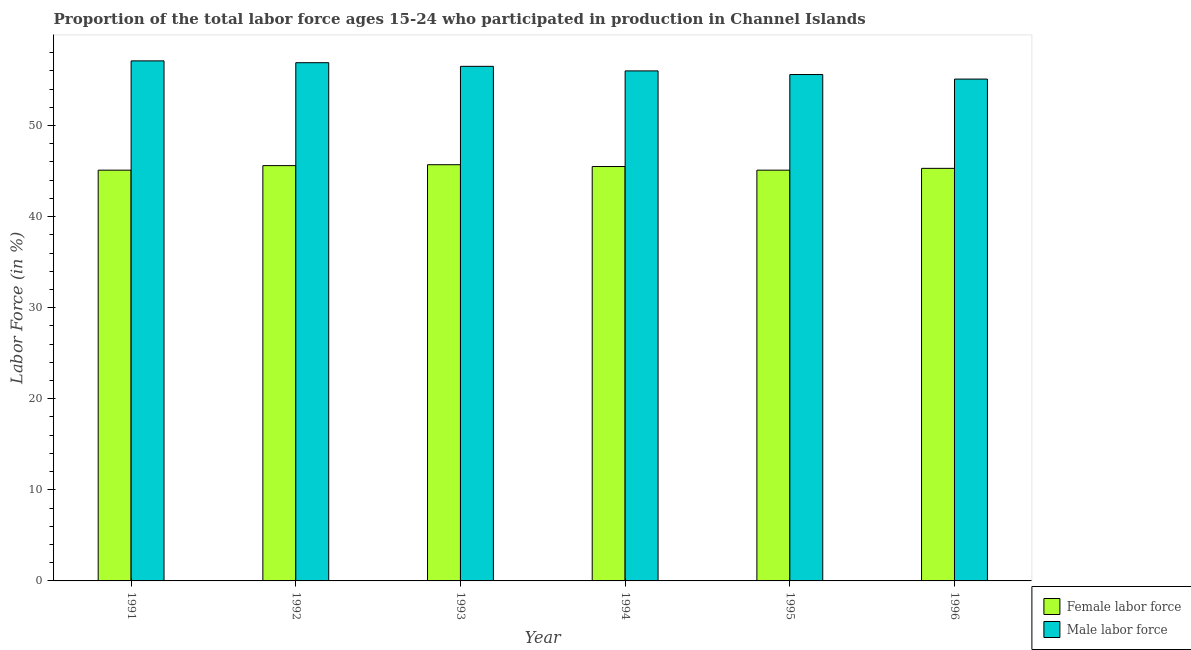How many groups of bars are there?
Your response must be concise. 6. Are the number of bars on each tick of the X-axis equal?
Make the answer very short. Yes. How many bars are there on the 2nd tick from the left?
Provide a short and direct response. 2. What is the label of the 3rd group of bars from the left?
Offer a very short reply. 1993. What is the percentage of male labour force in 1993?
Offer a terse response. 56.5. Across all years, what is the maximum percentage of female labor force?
Offer a terse response. 45.7. Across all years, what is the minimum percentage of male labour force?
Offer a terse response. 55.1. In which year was the percentage of male labour force maximum?
Ensure brevity in your answer.  1991. In which year was the percentage of male labour force minimum?
Your answer should be very brief. 1996. What is the total percentage of female labor force in the graph?
Offer a very short reply. 272.3. What is the difference between the percentage of male labour force in 1991 and that in 1993?
Ensure brevity in your answer.  0.6. What is the difference between the percentage of male labour force in 1996 and the percentage of female labor force in 1993?
Ensure brevity in your answer.  -1.4. What is the average percentage of male labour force per year?
Your answer should be very brief. 56.2. What is the ratio of the percentage of male labour force in 1991 to that in 1996?
Your answer should be very brief. 1.04. Is the percentage of male labour force in 1991 less than that in 1995?
Provide a short and direct response. No. Is the difference between the percentage of female labor force in 1992 and 1993 greater than the difference between the percentage of male labour force in 1992 and 1993?
Provide a short and direct response. No. What is the difference between the highest and the second highest percentage of female labor force?
Ensure brevity in your answer.  0.1. What is the difference between the highest and the lowest percentage of male labour force?
Your answer should be compact. 2. In how many years, is the percentage of female labor force greater than the average percentage of female labor force taken over all years?
Your answer should be very brief. 3. What does the 2nd bar from the left in 1991 represents?
Offer a very short reply. Male labor force. What does the 1st bar from the right in 1991 represents?
Provide a succinct answer. Male labor force. How many bars are there?
Your response must be concise. 12. Are the values on the major ticks of Y-axis written in scientific E-notation?
Provide a short and direct response. No. How many legend labels are there?
Ensure brevity in your answer.  2. How are the legend labels stacked?
Keep it short and to the point. Vertical. What is the title of the graph?
Your answer should be very brief. Proportion of the total labor force ages 15-24 who participated in production in Channel Islands. Does "US$" appear as one of the legend labels in the graph?
Give a very brief answer. No. What is the Labor Force (in %) of Female labor force in 1991?
Your response must be concise. 45.1. What is the Labor Force (in %) in Male labor force in 1991?
Your answer should be compact. 57.1. What is the Labor Force (in %) in Female labor force in 1992?
Your answer should be very brief. 45.6. What is the Labor Force (in %) in Male labor force in 1992?
Your response must be concise. 56.9. What is the Labor Force (in %) of Female labor force in 1993?
Offer a very short reply. 45.7. What is the Labor Force (in %) in Male labor force in 1993?
Your answer should be very brief. 56.5. What is the Labor Force (in %) in Female labor force in 1994?
Make the answer very short. 45.5. What is the Labor Force (in %) in Female labor force in 1995?
Offer a terse response. 45.1. What is the Labor Force (in %) of Male labor force in 1995?
Make the answer very short. 55.6. What is the Labor Force (in %) in Female labor force in 1996?
Your answer should be compact. 45.3. What is the Labor Force (in %) of Male labor force in 1996?
Ensure brevity in your answer.  55.1. Across all years, what is the maximum Labor Force (in %) in Female labor force?
Give a very brief answer. 45.7. Across all years, what is the maximum Labor Force (in %) in Male labor force?
Keep it short and to the point. 57.1. Across all years, what is the minimum Labor Force (in %) of Female labor force?
Give a very brief answer. 45.1. Across all years, what is the minimum Labor Force (in %) of Male labor force?
Ensure brevity in your answer.  55.1. What is the total Labor Force (in %) of Female labor force in the graph?
Ensure brevity in your answer.  272.3. What is the total Labor Force (in %) in Male labor force in the graph?
Give a very brief answer. 337.2. What is the difference between the Labor Force (in %) in Female labor force in 1991 and that in 1993?
Your answer should be compact. -0.6. What is the difference between the Labor Force (in %) of Female labor force in 1991 and that in 1994?
Offer a very short reply. -0.4. What is the difference between the Labor Force (in %) of Female labor force in 1991 and that in 1996?
Your response must be concise. -0.2. What is the difference between the Labor Force (in %) of Female labor force in 1992 and that in 1993?
Keep it short and to the point. -0.1. What is the difference between the Labor Force (in %) in Female labor force in 1992 and that in 1995?
Make the answer very short. 0.5. What is the difference between the Labor Force (in %) of Male labor force in 1992 and that in 1995?
Provide a succinct answer. 1.3. What is the difference between the Labor Force (in %) of Female labor force in 1992 and that in 1996?
Ensure brevity in your answer.  0.3. What is the difference between the Labor Force (in %) of Female labor force in 1993 and that in 1994?
Provide a succinct answer. 0.2. What is the difference between the Labor Force (in %) of Female labor force in 1993 and that in 1995?
Your response must be concise. 0.6. What is the difference between the Labor Force (in %) in Male labor force in 1993 and that in 1995?
Ensure brevity in your answer.  0.9. What is the difference between the Labor Force (in %) of Female labor force in 1993 and that in 1996?
Your response must be concise. 0.4. What is the difference between the Labor Force (in %) in Male labor force in 1993 and that in 1996?
Give a very brief answer. 1.4. What is the difference between the Labor Force (in %) in Male labor force in 1995 and that in 1996?
Make the answer very short. 0.5. What is the difference between the Labor Force (in %) of Female labor force in 1991 and the Labor Force (in %) of Male labor force in 1992?
Make the answer very short. -11.8. What is the difference between the Labor Force (in %) in Female labor force in 1991 and the Labor Force (in %) in Male labor force in 1993?
Provide a short and direct response. -11.4. What is the difference between the Labor Force (in %) of Female labor force in 1991 and the Labor Force (in %) of Male labor force in 1996?
Offer a terse response. -10. What is the difference between the Labor Force (in %) of Female labor force in 1992 and the Labor Force (in %) of Male labor force in 1994?
Provide a succinct answer. -10.4. What is the difference between the Labor Force (in %) of Female labor force in 1992 and the Labor Force (in %) of Male labor force in 1995?
Your answer should be compact. -10. What is the difference between the Labor Force (in %) of Female labor force in 1992 and the Labor Force (in %) of Male labor force in 1996?
Your response must be concise. -9.5. What is the difference between the Labor Force (in %) of Female labor force in 1995 and the Labor Force (in %) of Male labor force in 1996?
Your response must be concise. -10. What is the average Labor Force (in %) in Female labor force per year?
Provide a succinct answer. 45.38. What is the average Labor Force (in %) of Male labor force per year?
Your answer should be very brief. 56.2. In the year 1995, what is the difference between the Labor Force (in %) in Female labor force and Labor Force (in %) in Male labor force?
Ensure brevity in your answer.  -10.5. In the year 1996, what is the difference between the Labor Force (in %) of Female labor force and Labor Force (in %) of Male labor force?
Your answer should be very brief. -9.8. What is the ratio of the Labor Force (in %) of Female labor force in 1991 to that in 1992?
Make the answer very short. 0.99. What is the ratio of the Labor Force (in %) of Male labor force in 1991 to that in 1992?
Ensure brevity in your answer.  1. What is the ratio of the Labor Force (in %) in Female labor force in 1991 to that in 1993?
Provide a short and direct response. 0.99. What is the ratio of the Labor Force (in %) in Male labor force in 1991 to that in 1993?
Your answer should be compact. 1.01. What is the ratio of the Labor Force (in %) in Male labor force in 1991 to that in 1994?
Offer a very short reply. 1.02. What is the ratio of the Labor Force (in %) in Female labor force in 1991 to that in 1995?
Your answer should be compact. 1. What is the ratio of the Labor Force (in %) in Male labor force in 1991 to that in 1995?
Your response must be concise. 1.03. What is the ratio of the Labor Force (in %) in Female labor force in 1991 to that in 1996?
Make the answer very short. 1. What is the ratio of the Labor Force (in %) of Male labor force in 1991 to that in 1996?
Your response must be concise. 1.04. What is the ratio of the Labor Force (in %) of Male labor force in 1992 to that in 1993?
Provide a succinct answer. 1.01. What is the ratio of the Labor Force (in %) in Male labor force in 1992 to that in 1994?
Offer a terse response. 1.02. What is the ratio of the Labor Force (in %) of Female labor force in 1992 to that in 1995?
Your response must be concise. 1.01. What is the ratio of the Labor Force (in %) of Male labor force in 1992 to that in 1995?
Provide a short and direct response. 1.02. What is the ratio of the Labor Force (in %) in Female labor force in 1992 to that in 1996?
Give a very brief answer. 1.01. What is the ratio of the Labor Force (in %) in Male labor force in 1992 to that in 1996?
Your response must be concise. 1.03. What is the ratio of the Labor Force (in %) of Female labor force in 1993 to that in 1994?
Your answer should be very brief. 1. What is the ratio of the Labor Force (in %) of Male labor force in 1993 to that in 1994?
Your answer should be very brief. 1.01. What is the ratio of the Labor Force (in %) in Female labor force in 1993 to that in 1995?
Your answer should be very brief. 1.01. What is the ratio of the Labor Force (in %) of Male labor force in 1993 to that in 1995?
Your answer should be compact. 1.02. What is the ratio of the Labor Force (in %) of Female labor force in 1993 to that in 1996?
Offer a very short reply. 1.01. What is the ratio of the Labor Force (in %) of Male labor force in 1993 to that in 1996?
Keep it short and to the point. 1.03. What is the ratio of the Labor Force (in %) in Female labor force in 1994 to that in 1995?
Provide a short and direct response. 1.01. What is the ratio of the Labor Force (in %) in Male labor force in 1994 to that in 1995?
Offer a very short reply. 1.01. What is the ratio of the Labor Force (in %) in Male labor force in 1994 to that in 1996?
Give a very brief answer. 1.02. What is the ratio of the Labor Force (in %) of Male labor force in 1995 to that in 1996?
Your response must be concise. 1.01. What is the difference between the highest and the second highest Labor Force (in %) in Female labor force?
Offer a very short reply. 0.1. What is the difference between the highest and the second highest Labor Force (in %) of Male labor force?
Your answer should be compact. 0.2. What is the difference between the highest and the lowest Labor Force (in %) in Male labor force?
Your answer should be compact. 2. 